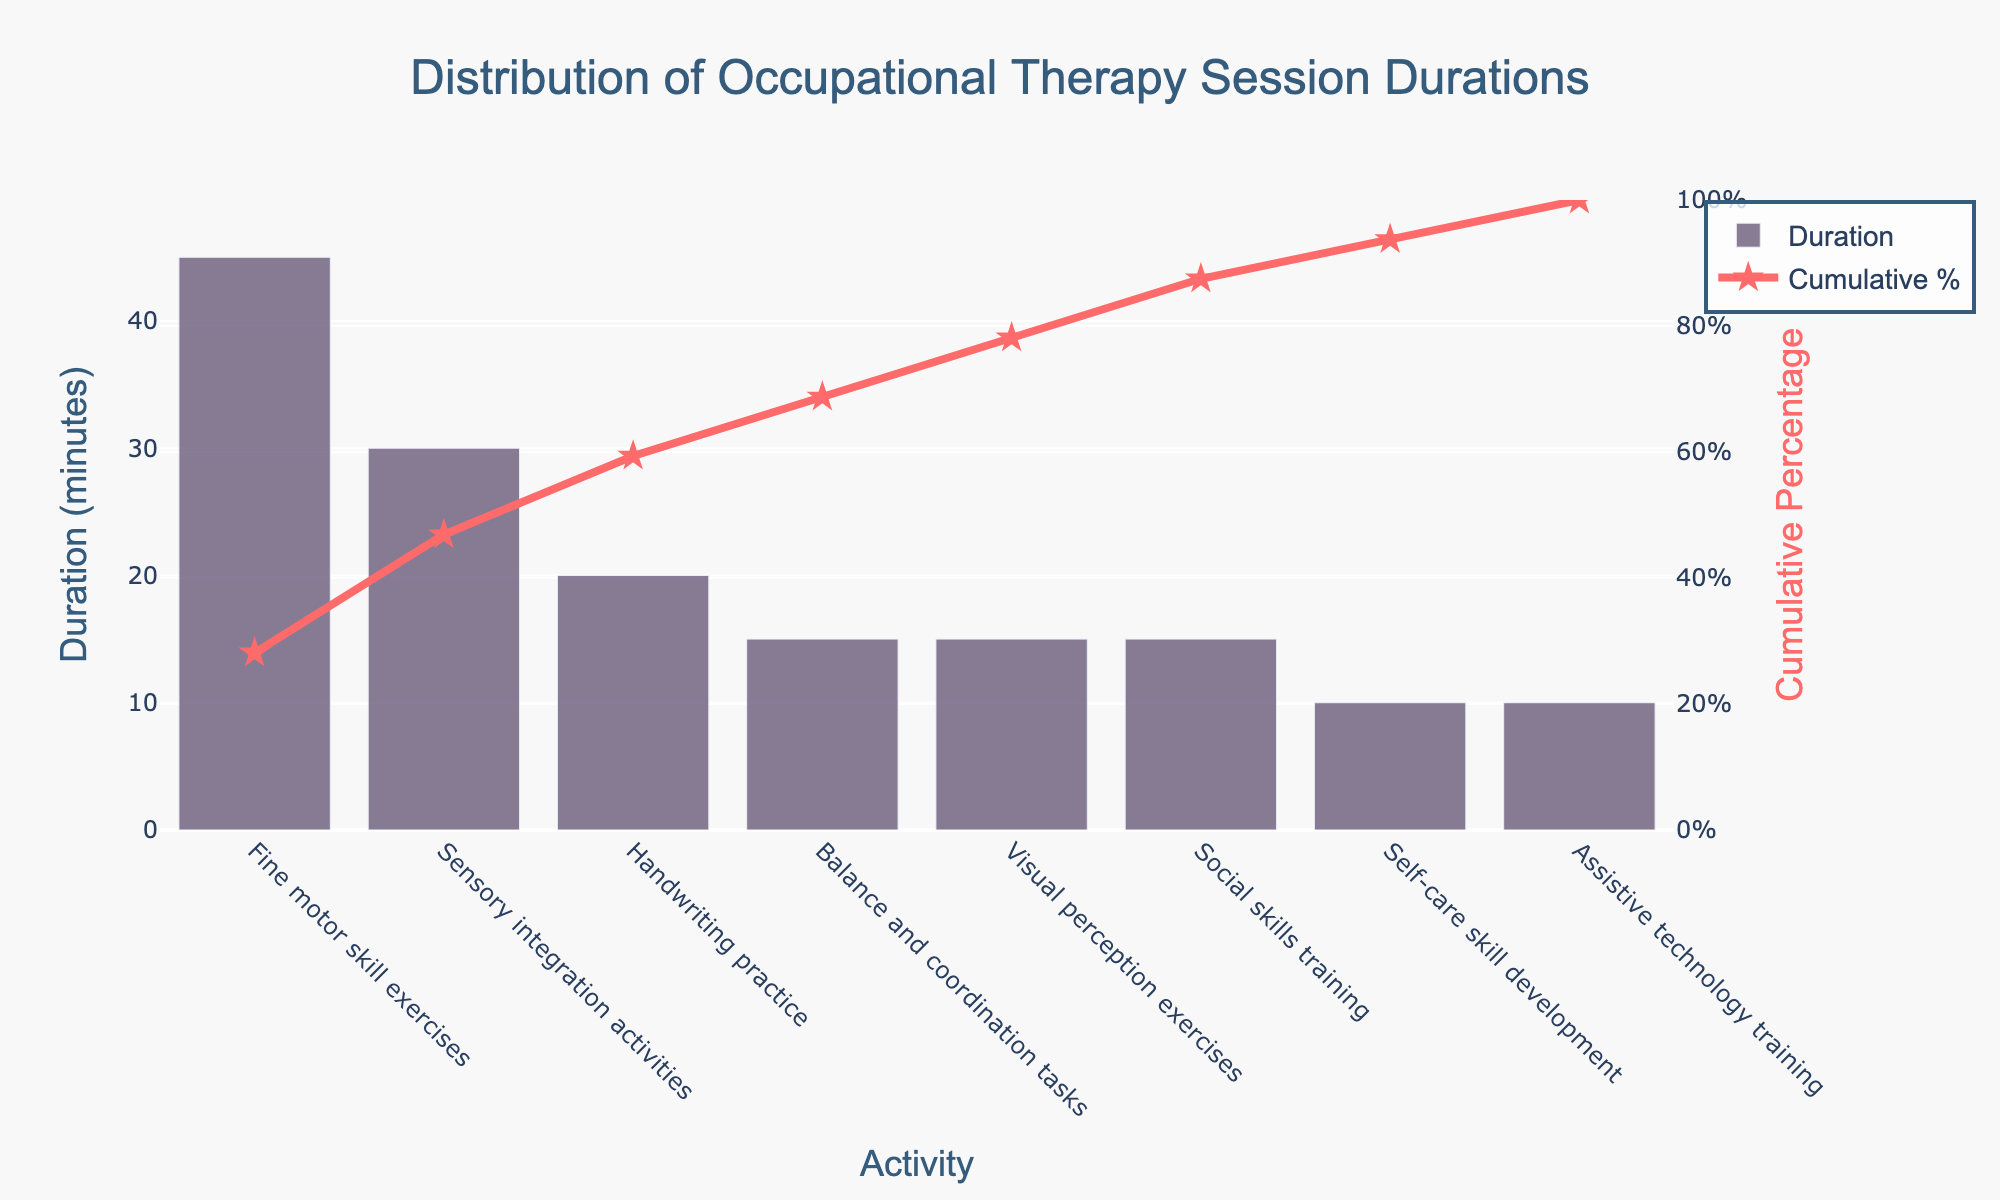What is the title of the chart? The title of the chart is usually displayed at the top of the figure. From the given data and code, we know the title is set as "Distribution of Occupational Therapy Session Durations".
Answer: Distribution of Occupational Therapy Session Durations Which activity has the longest duration? The Pareto chart displays activities in decreasing order of duration. The first activity in the chart or the one with the highest bar represents the longest duration, which is "Fine motor skill exercises" at 45 minutes.
Answer: Fine motor skill exercises Which activities have the same duration? To find activities with the same duration, check for bars that are of equal height. According to the data, “Balance and coordination tasks”, “Visual perception exercises”, and “Social skills training” each have a duration of 15 minutes. Moreover, “Self-care skill development” and “Assistive technology training” each have a duration of 10 minutes.
Answer: Balance and coordination tasks & Visual perception exercises & Social skills training; Self-care skill development & Assistive technology training What is the cumulative percentage after Sensory integration activities? The cumulative percentage after Sensory integration activities can be found from the data and corresponding line chart. Sensory integration activities have a cumulative percentage of 46.88%.
Answer: 46.88% How many categories have durations longer than 20 minutes? To find how many categories have durations longer than 20 minutes, count the bars with heights greater than 20 on the chart. In the provided data, "Fine motor skill exercises" and "Sensory integration activities" have durations longer than 20 minutes.
Answer: 2 What is the average duration of all activities? To calculate the average duration, sum all the durations and divide by the number of activities. Sum (45 + 30 + 20 + 15 + 15 + 15 + 10 + 10) = 160 minutes. With 8 activities, the average duration is 160 / 8 = 20 minutes.
Answer: 20 minutes Which activity has the smallest contribution to the cumulative percentage? The smallest contribution is represented by the last item in the cumulative chart. From the data, "Assistive technology training" and "Self-care skill development" each add 10 minutes and raise the cumulative percentage to 100% and 93.75% respectively.
Answer: Assistive technology training What is the percentage difference between Fine motor skill exercises and Handwriting practice? To find the percentage difference between these two activities: Cumulative percentage after Fine motor skill exercises is 28.13%. After Handwriting practice, it is 59.38%. The difference is 59.38% - 28.13% = 31.25%.
Answer: 31.25% 